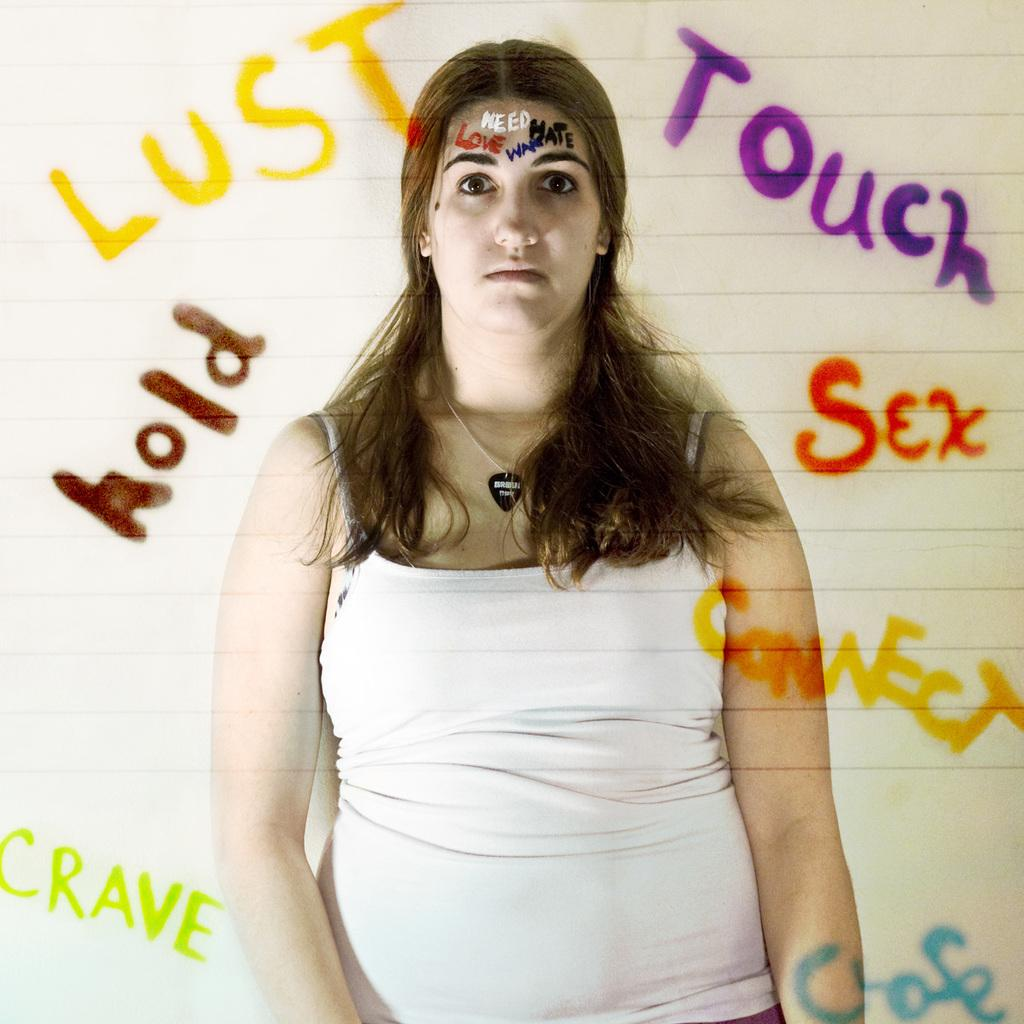What is the main subject of the image? There is a lady in the image. What is unique about the lady's appearance? There is text on the lady's forehead. Can you describe the background of the image? There is text visible in the background of the image. How many ears does the lady have in the image? The image does not show the lady's ears, so it cannot be determined how many she has. 